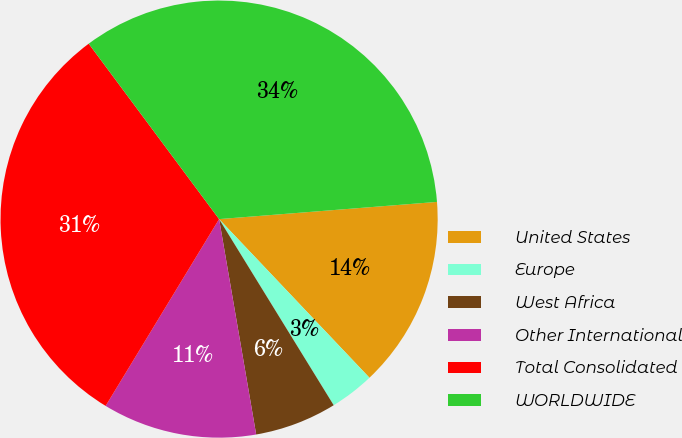Convert chart to OTSL. <chart><loc_0><loc_0><loc_500><loc_500><pie_chart><fcel>United States<fcel>Europe<fcel>West Africa<fcel>Other International<fcel>Total Consolidated<fcel>WORLDWIDE<nl><fcel>14.18%<fcel>3.29%<fcel>6.07%<fcel>11.4%<fcel>31.14%<fcel>33.92%<nl></chart> 